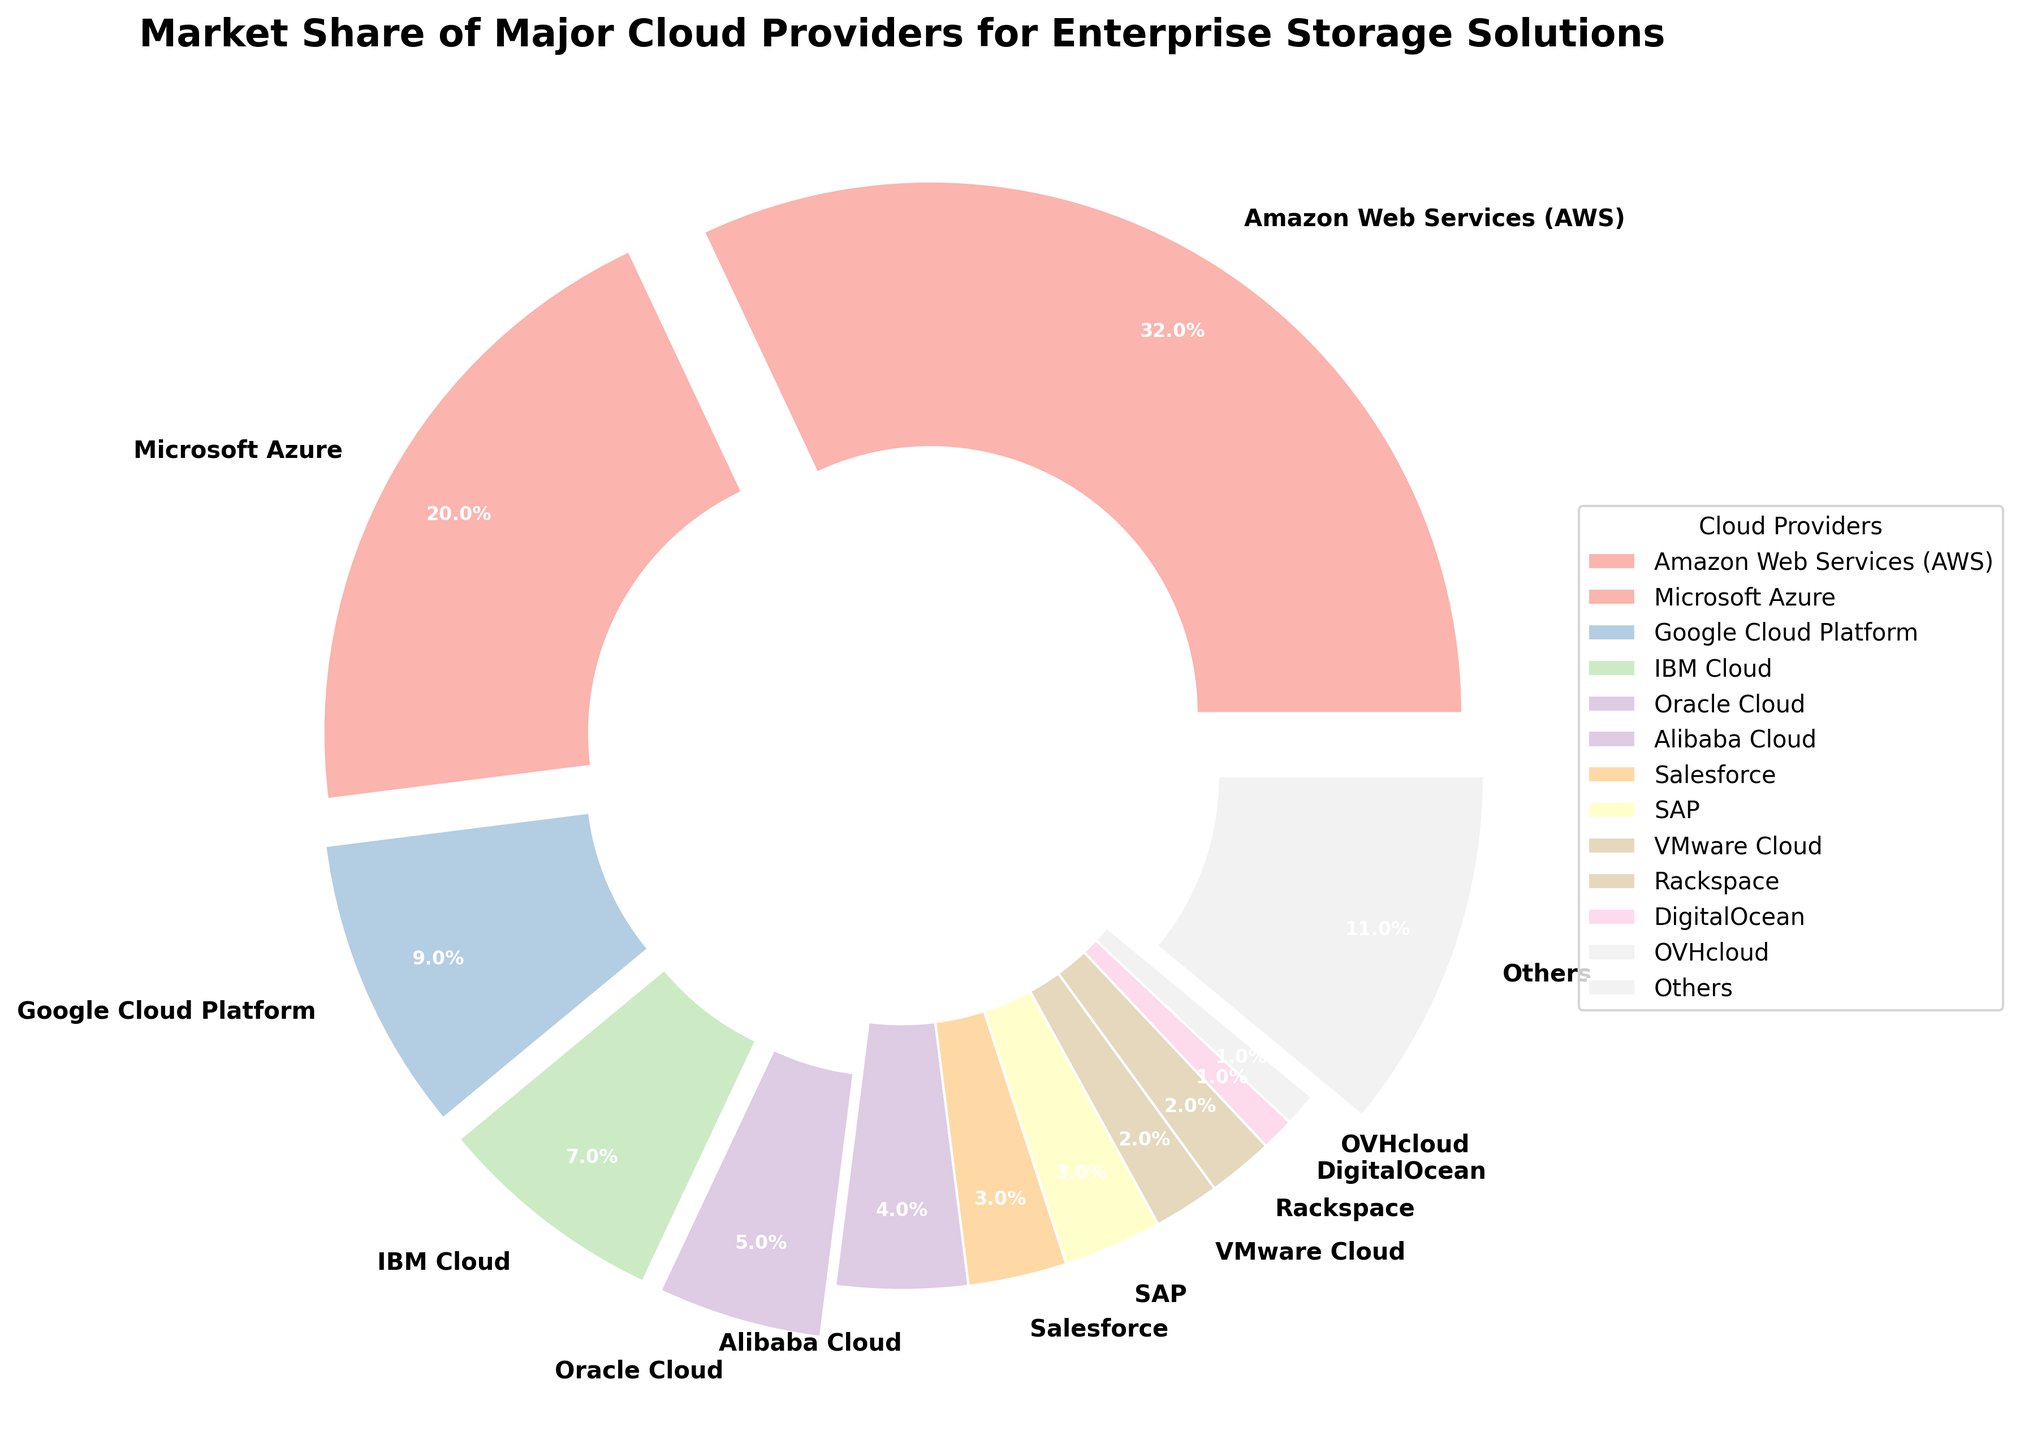Which cloud provider has the highest market share? The AWS segment represents the largest slice of the pie chart, which indicates the highest market share.
Answer: Amazon Web Services (AWS) What is the combined market share of the top two cloud providers? AWS has a market share of 32%, and Microsoft Azure has a market share of 20%. Adding them up gives 32% + 20% = 52%.
Answer: 52% How much larger is the market share of AWS compared to Google Cloud Platform? AWS has a market share of 32%, whereas Google Cloud Platform has 9%. The difference is 32% - 9% = 23%.
Answer: 23% Which providers have a market share greater than or equal to 5%? Examine the pie chart and identify the segments with an exploded slice. AWS, Microsoft Azure, Google Cloud Platform, IBM Cloud, and Oracle Cloud have market shares of 32%, 20%, 9%, 7%, and 5%, respectively, which are all greater than or equal to 5%.
Answer: AWS, Microsoft Azure, Google Cloud Platform, IBM Cloud, Oracle Cloud What is the market share of the smallest cloud provider? DigitalOcean and OVHcloud have the smallest slices of the pie chart, each representing 1%.
Answer: 1% What is the cumulative market share of providers with less than 5% each? The market shares of providers with less than 5% are summed: Alibaba Cloud (4%), Salesforce (3%), SAP (3%), VMware Cloud (2%), Rackspace (2%), DigitalOcean (1%), OVHcloud (1%), and Others (11%). Adding these percentages gives 4% + 3% + 3% + 2% + 2% + 1% + 1% + 11% = 27%.
Answer: 27% How does the market share of Oracle Cloud compare to that of IBM Cloud? Oracle Cloud has a market share of 5%, while IBM Cloud has a market share of 7%. Thus, IBM Cloud's market share is 2% larger than Oracle Cloud's market share.
Answer: IBM Cloud has 2% more market share than Oracle Cloud What providers make up the majority of the market share (greater than 50%)? AWS (32%) and Microsoft Azure (20%) together make up more than 50% of the market share since 32% + 20% = 52%.
Answer: AWS and Microsoft Azure What visual feature is used to emphasize specific providers in the chart? The chart uses an "explode" effect to highlight the wedges of providers with a market share of 5% or more, making them appear separated from the rest.
Answer: Explode effect What percentage of the market share is held by companies categorized as "Others"? The segment labeled "Others" in the pie chart accounts for 11% of the market share.
Answer: 11% 